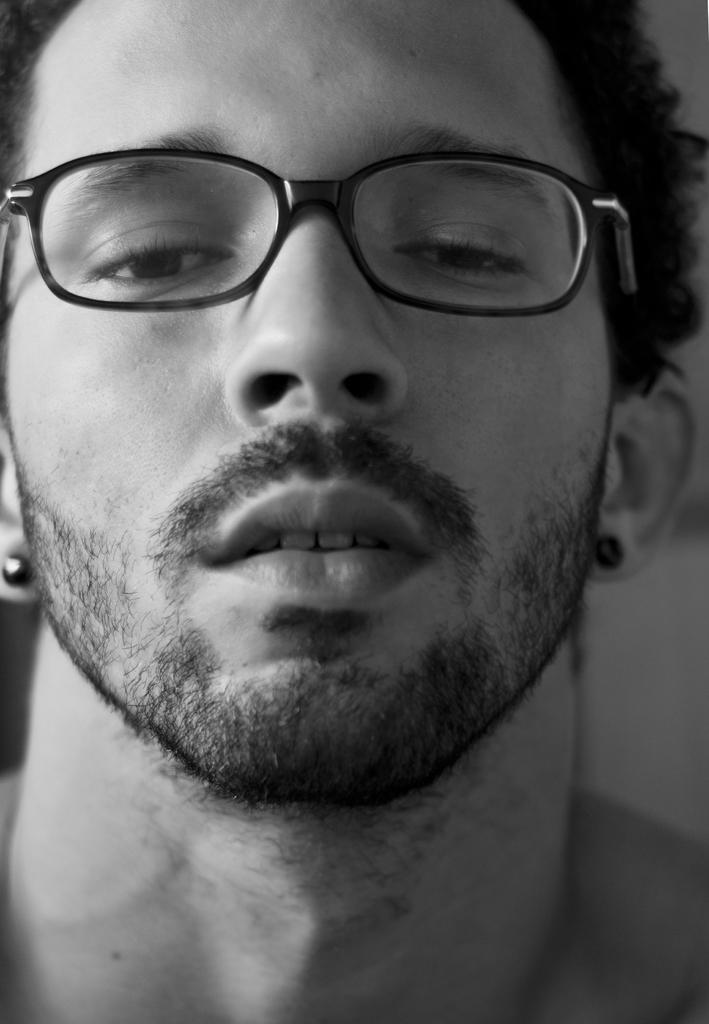What is the color scheme of the image? The image is black and white. Can you describe the main subject of the image? There is a person in the image. What accessory is the person wearing? The person is wearing spectacles. How many people are in the crowd in the image? There is no crowd present in the image; it features a single person wearing spectacles. What type of beggar can be seen in the image? There is no beggar present in the image; it features a person wearing spectacles. 